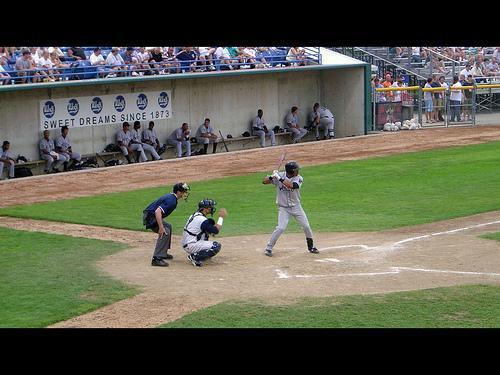How many people wear in orange?
Give a very brief answer. 1. 